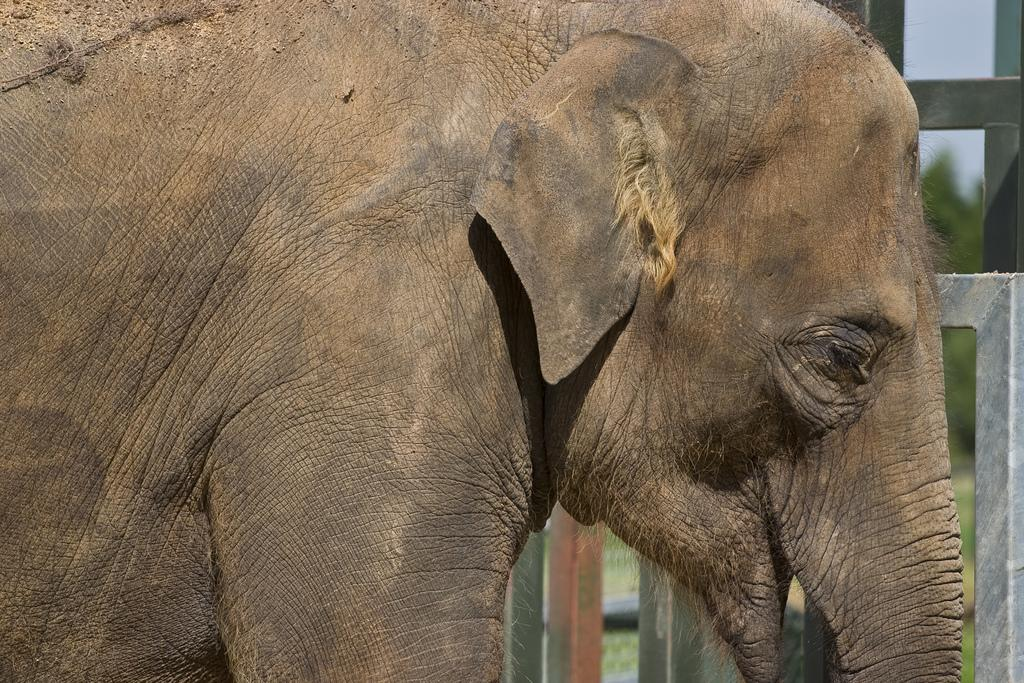What animal can be seen in the picture? There is an elephant in the picture. What type of fencing can be seen in the background? There is wooden fencing in the background. What natural elements are visible in the background? Trees, plants, grass, and the sky are visible in the background. Where is the lake located in the image? There is no lake present in the image. What type of error can be seen in the image? There is no error present in the image. 